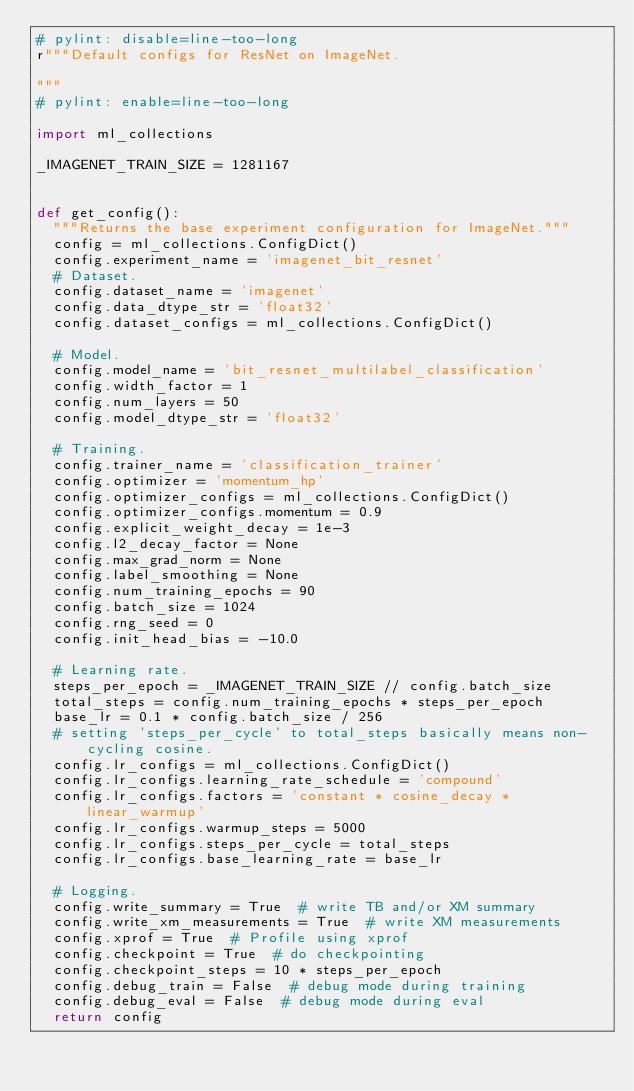<code> <loc_0><loc_0><loc_500><loc_500><_Python_># pylint: disable=line-too-long
r"""Default configs for ResNet on ImageNet.

"""
# pylint: enable=line-too-long

import ml_collections

_IMAGENET_TRAIN_SIZE = 1281167


def get_config():
  """Returns the base experiment configuration for ImageNet."""
  config = ml_collections.ConfigDict()
  config.experiment_name = 'imagenet_bit_resnet'
  # Dataset.
  config.dataset_name = 'imagenet'
  config.data_dtype_str = 'float32'
  config.dataset_configs = ml_collections.ConfigDict()

  # Model.
  config.model_name = 'bit_resnet_multilabel_classification'
  config.width_factor = 1
  config.num_layers = 50
  config.model_dtype_str = 'float32'

  # Training.
  config.trainer_name = 'classification_trainer'
  config.optimizer = 'momentum_hp'
  config.optimizer_configs = ml_collections.ConfigDict()
  config.optimizer_configs.momentum = 0.9
  config.explicit_weight_decay = 1e-3
  config.l2_decay_factor = None
  config.max_grad_norm = None
  config.label_smoothing = None
  config.num_training_epochs = 90
  config.batch_size = 1024
  config.rng_seed = 0
  config.init_head_bias = -10.0

  # Learning rate.
  steps_per_epoch = _IMAGENET_TRAIN_SIZE // config.batch_size
  total_steps = config.num_training_epochs * steps_per_epoch
  base_lr = 0.1 * config.batch_size / 256
  # setting 'steps_per_cycle' to total_steps basically means non-cycling cosine.
  config.lr_configs = ml_collections.ConfigDict()
  config.lr_configs.learning_rate_schedule = 'compound'
  config.lr_configs.factors = 'constant * cosine_decay * linear_warmup'
  config.lr_configs.warmup_steps = 5000
  config.lr_configs.steps_per_cycle = total_steps
  config.lr_configs.base_learning_rate = base_lr

  # Logging.
  config.write_summary = True  # write TB and/or XM summary
  config.write_xm_measurements = True  # write XM measurements
  config.xprof = True  # Profile using xprof
  config.checkpoint = True  # do checkpointing
  config.checkpoint_steps = 10 * steps_per_epoch
  config.debug_train = False  # debug mode during training
  config.debug_eval = False  # debug mode during eval
  return config


</code> 